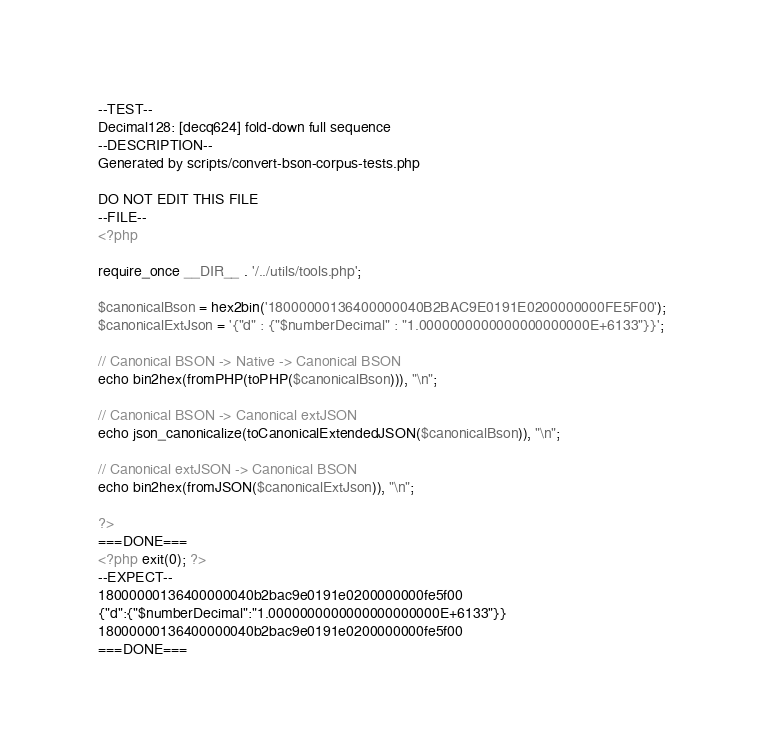<code> <loc_0><loc_0><loc_500><loc_500><_PHP_>--TEST--
Decimal128: [decq624] fold-down full sequence
--DESCRIPTION--
Generated by scripts/convert-bson-corpus-tests.php

DO NOT EDIT THIS FILE
--FILE--
<?php

require_once __DIR__ . '/../utils/tools.php';

$canonicalBson = hex2bin('18000000136400000040B2BAC9E0191E0200000000FE5F00');
$canonicalExtJson = '{"d" : {"$numberDecimal" : "1.0000000000000000000000E+6133"}}';

// Canonical BSON -> Native -> Canonical BSON 
echo bin2hex(fromPHP(toPHP($canonicalBson))), "\n";

// Canonical BSON -> Canonical extJSON 
echo json_canonicalize(toCanonicalExtendedJSON($canonicalBson)), "\n";

// Canonical extJSON -> Canonical BSON 
echo bin2hex(fromJSON($canonicalExtJson)), "\n";

?>
===DONE===
<?php exit(0); ?>
--EXPECT--
18000000136400000040b2bac9e0191e0200000000fe5f00
{"d":{"$numberDecimal":"1.0000000000000000000000E+6133"}}
18000000136400000040b2bac9e0191e0200000000fe5f00
===DONE===</code> 